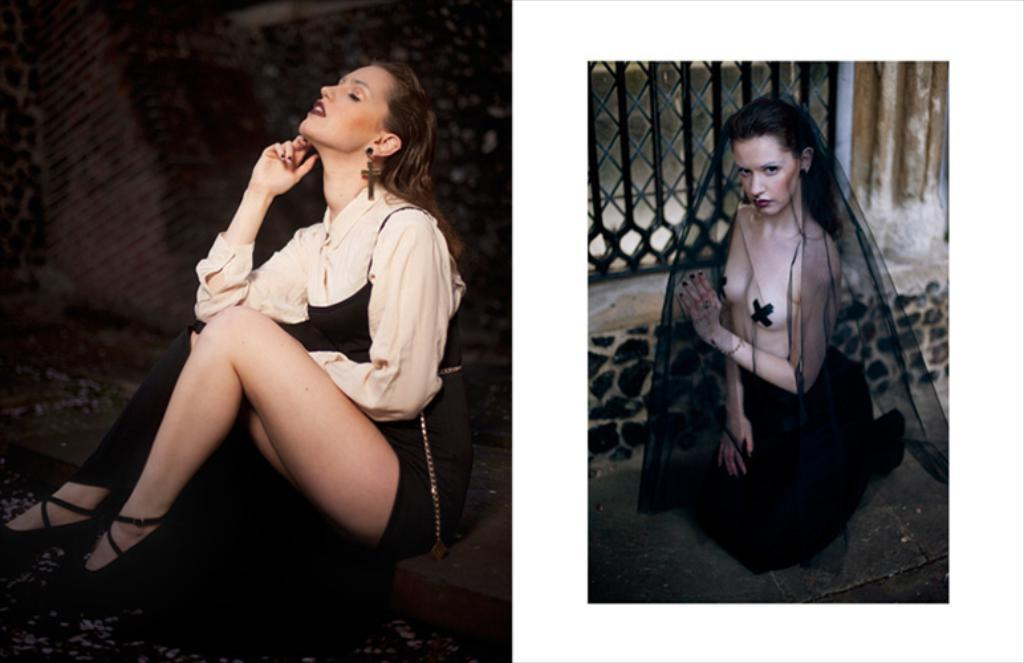What type of artwork is depicted in the image? The image is a collage. What can be seen in the first part of the collage? In the first part of the collage, there is a woman wearing a dress. What is featured in the second part of the collage? In the second part of the collage, there are women wearing half clothes. What flavor of ice cream is being exchanged between the women in the collage? There is no ice cream present in the image, and no exchange of any items is depicted. 